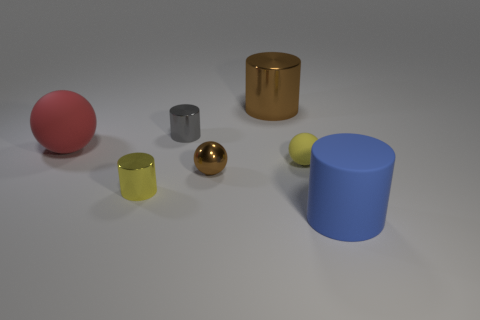Add 3 large red balls. How many objects exist? 10 Subtract all cyan cylinders. Subtract all purple blocks. How many cylinders are left? 4 Subtract all cylinders. How many objects are left? 3 Add 1 brown rubber spheres. How many brown rubber spheres exist? 1 Subtract 1 blue cylinders. How many objects are left? 6 Subtract all big green cylinders. Subtract all yellow rubber things. How many objects are left? 6 Add 6 blue rubber cylinders. How many blue rubber cylinders are left? 7 